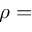<formula> <loc_0><loc_0><loc_500><loc_500>\rho =</formula> 